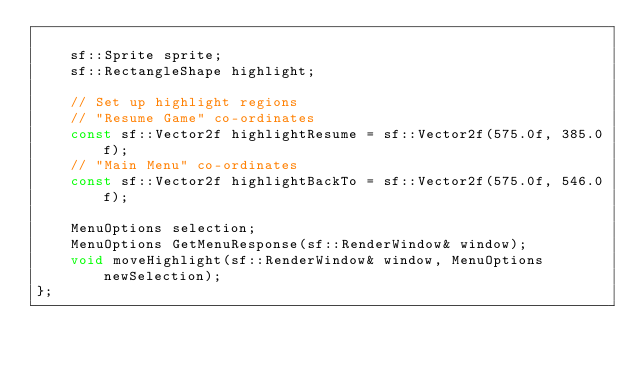<code> <loc_0><loc_0><loc_500><loc_500><_C_>
	sf::Sprite sprite;
	sf::RectangleShape highlight;

	// Set up highlight regions
	// "Resume Game" co-ordinates
	const sf::Vector2f highlightResume = sf::Vector2f(575.0f, 385.0f);
	// "Main Menu" co-ordinates
	const sf::Vector2f highlightBackTo = sf::Vector2f(575.0f, 546.0f);

	MenuOptions selection;
	MenuOptions GetMenuResponse(sf::RenderWindow& window);
	void moveHighlight(sf::RenderWindow& window, MenuOptions newSelection);
};</code> 